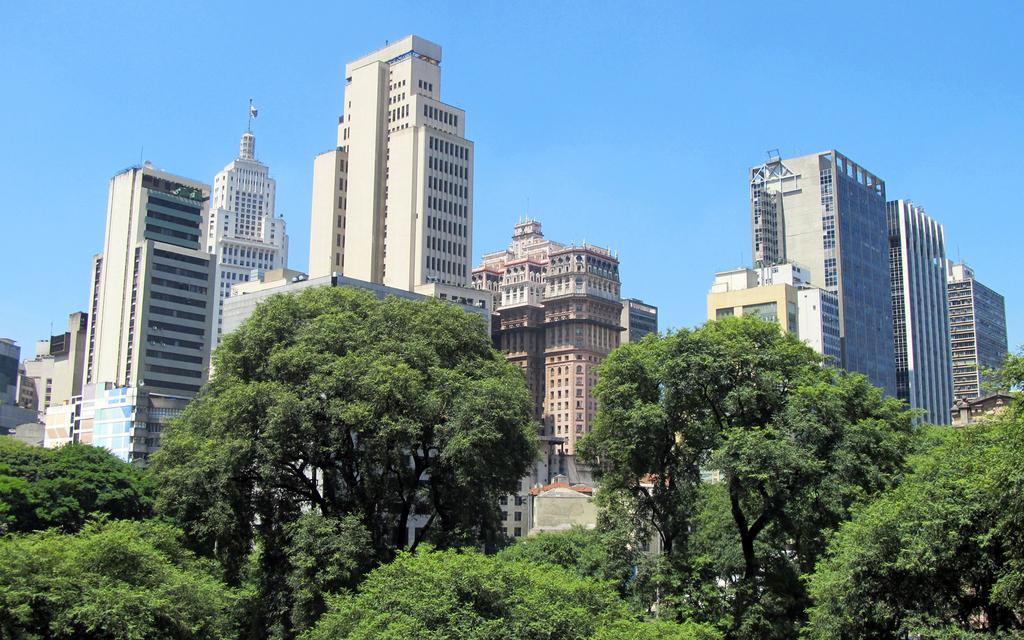Can you describe this image briefly? In this image I can see few trees in green color, background I can see few buildings in white, cream and brown color and the sky is in blue color. 